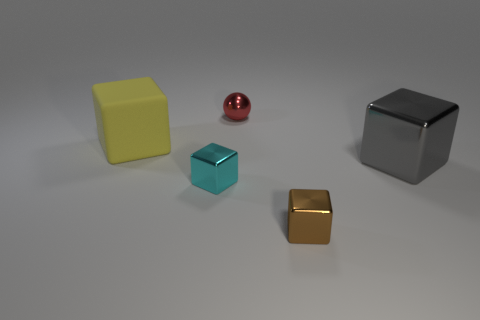There is a large gray object that is the same shape as the small cyan object; what is its material?
Provide a succinct answer. Metal. Are there any other things that have the same material as the yellow block?
Give a very brief answer. No. Is the material of the big gray cube the same as the big block that is on the left side of the small red thing?
Your answer should be very brief. No. What is the shape of the small thing that is behind the big cube that is right of the brown metal block?
Your answer should be very brief. Sphere. What number of tiny objects are gray objects or metallic cubes?
Your answer should be very brief. 2. How many other small brown metallic things have the same shape as the brown thing?
Keep it short and to the point. 0. There is a small brown shiny thing; is its shape the same as the big thing that is right of the brown cube?
Keep it short and to the point. Yes. There is a small red ball; what number of big cubes are left of it?
Ensure brevity in your answer.  1. Is there a sphere that has the same size as the red metal object?
Keep it short and to the point. No. Do the thing that is right of the brown shiny thing and the big yellow matte thing have the same shape?
Offer a terse response. Yes. 